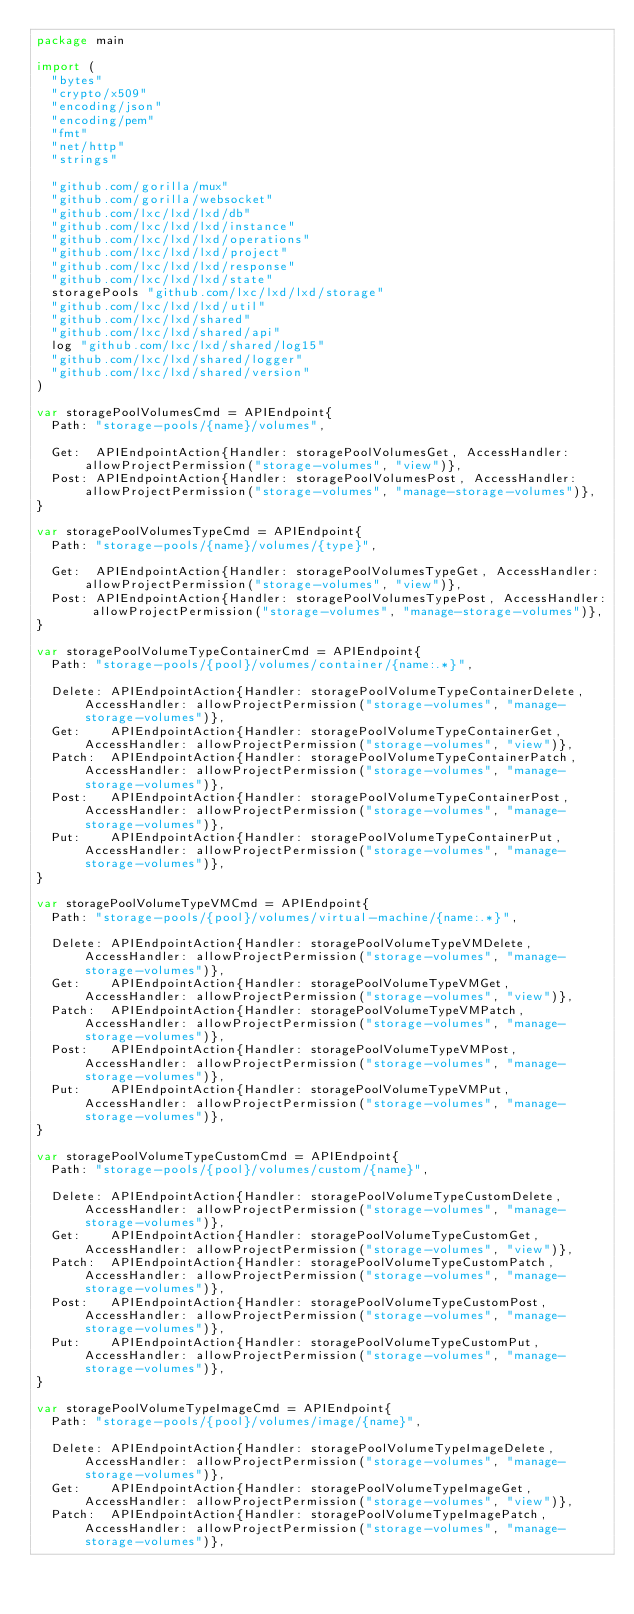Convert code to text. <code><loc_0><loc_0><loc_500><loc_500><_Go_>package main

import (
	"bytes"
	"crypto/x509"
	"encoding/json"
	"encoding/pem"
	"fmt"
	"net/http"
	"strings"

	"github.com/gorilla/mux"
	"github.com/gorilla/websocket"
	"github.com/lxc/lxd/lxd/db"
	"github.com/lxc/lxd/lxd/instance"
	"github.com/lxc/lxd/lxd/operations"
	"github.com/lxc/lxd/lxd/project"
	"github.com/lxc/lxd/lxd/response"
	"github.com/lxc/lxd/lxd/state"
	storagePools "github.com/lxc/lxd/lxd/storage"
	"github.com/lxc/lxd/lxd/util"
	"github.com/lxc/lxd/shared"
	"github.com/lxc/lxd/shared/api"
	log "github.com/lxc/lxd/shared/log15"
	"github.com/lxc/lxd/shared/logger"
	"github.com/lxc/lxd/shared/version"
)

var storagePoolVolumesCmd = APIEndpoint{
	Path: "storage-pools/{name}/volumes",

	Get:  APIEndpointAction{Handler: storagePoolVolumesGet, AccessHandler: allowProjectPermission("storage-volumes", "view")},
	Post: APIEndpointAction{Handler: storagePoolVolumesPost, AccessHandler: allowProjectPermission("storage-volumes", "manage-storage-volumes")},
}

var storagePoolVolumesTypeCmd = APIEndpoint{
	Path: "storage-pools/{name}/volumes/{type}",

	Get:  APIEndpointAction{Handler: storagePoolVolumesTypeGet, AccessHandler: allowProjectPermission("storage-volumes", "view")},
	Post: APIEndpointAction{Handler: storagePoolVolumesTypePost, AccessHandler: allowProjectPermission("storage-volumes", "manage-storage-volumes")},
}

var storagePoolVolumeTypeContainerCmd = APIEndpoint{
	Path: "storage-pools/{pool}/volumes/container/{name:.*}",

	Delete: APIEndpointAction{Handler: storagePoolVolumeTypeContainerDelete, AccessHandler: allowProjectPermission("storage-volumes", "manage-storage-volumes")},
	Get:    APIEndpointAction{Handler: storagePoolVolumeTypeContainerGet, AccessHandler: allowProjectPermission("storage-volumes", "view")},
	Patch:  APIEndpointAction{Handler: storagePoolVolumeTypeContainerPatch, AccessHandler: allowProjectPermission("storage-volumes", "manage-storage-volumes")},
	Post:   APIEndpointAction{Handler: storagePoolVolumeTypeContainerPost, AccessHandler: allowProjectPermission("storage-volumes", "manage-storage-volumes")},
	Put:    APIEndpointAction{Handler: storagePoolVolumeTypeContainerPut, AccessHandler: allowProjectPermission("storage-volumes", "manage-storage-volumes")},
}

var storagePoolVolumeTypeVMCmd = APIEndpoint{
	Path: "storage-pools/{pool}/volumes/virtual-machine/{name:.*}",

	Delete: APIEndpointAction{Handler: storagePoolVolumeTypeVMDelete, AccessHandler: allowProjectPermission("storage-volumes", "manage-storage-volumes")},
	Get:    APIEndpointAction{Handler: storagePoolVolumeTypeVMGet, AccessHandler: allowProjectPermission("storage-volumes", "view")},
	Patch:  APIEndpointAction{Handler: storagePoolVolumeTypeVMPatch, AccessHandler: allowProjectPermission("storage-volumes", "manage-storage-volumes")},
	Post:   APIEndpointAction{Handler: storagePoolVolumeTypeVMPost, AccessHandler: allowProjectPermission("storage-volumes", "manage-storage-volumes")},
	Put:    APIEndpointAction{Handler: storagePoolVolumeTypeVMPut, AccessHandler: allowProjectPermission("storage-volumes", "manage-storage-volumes")},
}

var storagePoolVolumeTypeCustomCmd = APIEndpoint{
	Path: "storage-pools/{pool}/volumes/custom/{name}",

	Delete: APIEndpointAction{Handler: storagePoolVolumeTypeCustomDelete, AccessHandler: allowProjectPermission("storage-volumes", "manage-storage-volumes")},
	Get:    APIEndpointAction{Handler: storagePoolVolumeTypeCustomGet, AccessHandler: allowProjectPermission("storage-volumes", "view")},
	Patch:  APIEndpointAction{Handler: storagePoolVolumeTypeCustomPatch, AccessHandler: allowProjectPermission("storage-volumes", "manage-storage-volumes")},
	Post:   APIEndpointAction{Handler: storagePoolVolumeTypeCustomPost, AccessHandler: allowProjectPermission("storage-volumes", "manage-storage-volumes")},
	Put:    APIEndpointAction{Handler: storagePoolVolumeTypeCustomPut, AccessHandler: allowProjectPermission("storage-volumes", "manage-storage-volumes")},
}

var storagePoolVolumeTypeImageCmd = APIEndpoint{
	Path: "storage-pools/{pool}/volumes/image/{name}",

	Delete: APIEndpointAction{Handler: storagePoolVolumeTypeImageDelete, AccessHandler: allowProjectPermission("storage-volumes", "manage-storage-volumes")},
	Get:    APIEndpointAction{Handler: storagePoolVolumeTypeImageGet, AccessHandler: allowProjectPermission("storage-volumes", "view")},
	Patch:  APIEndpointAction{Handler: storagePoolVolumeTypeImagePatch, AccessHandler: allowProjectPermission("storage-volumes", "manage-storage-volumes")},</code> 